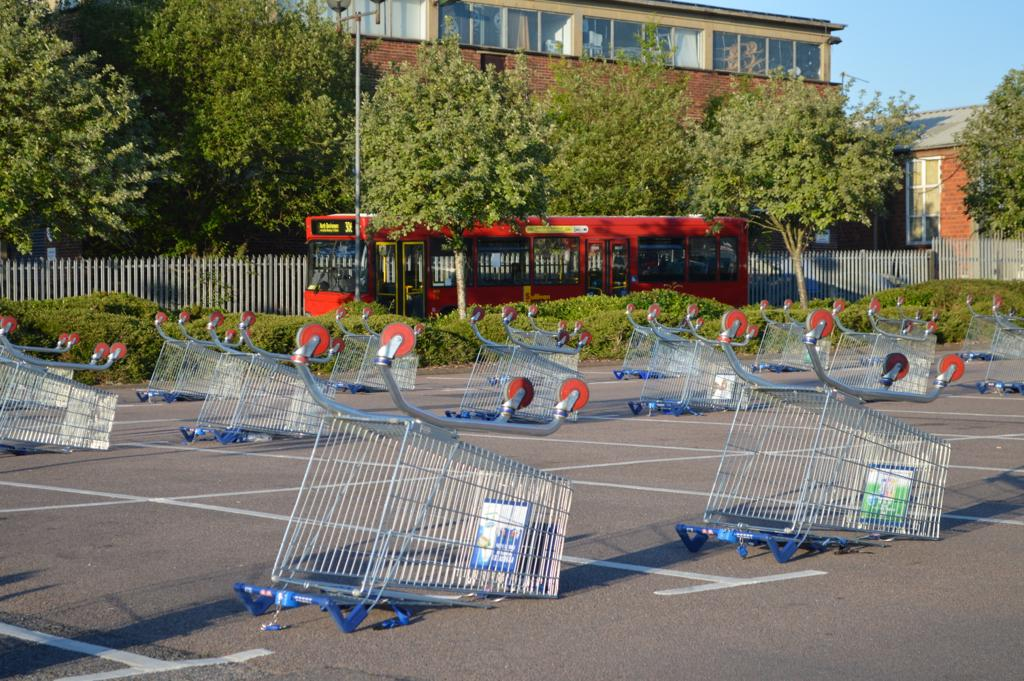What can be seen on the road in the image? There are carts on the road in the image. What type of vegetation is present in the image? There are plants and trees in the image. What structure can be seen in the image? There is a fence in the image. What object is present in the image that might be used for support or attachment? There is a pole in the image. What mode of transportation is visible in the image? There is a vehicle in the image. What type of man-made structures can be seen in the image? There are buildings in the image. What part of the natural environment is visible in the background of the image? The sky is visible in the background of the image. Is there a maid visible in the image? There is no mention of a maid in the provided facts, and therefore we cannot determine if one is present in the image. 